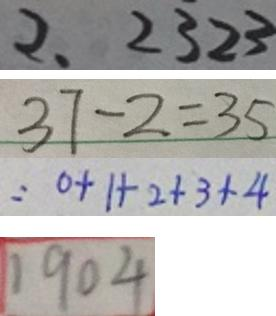<formula> <loc_0><loc_0><loc_500><loc_500>2 . 2 3 2 3 
 3 7 - 2 = 3 5 
 = 0 + 1 + 2 + 3 + 4 
 1 9 0 4</formula> 